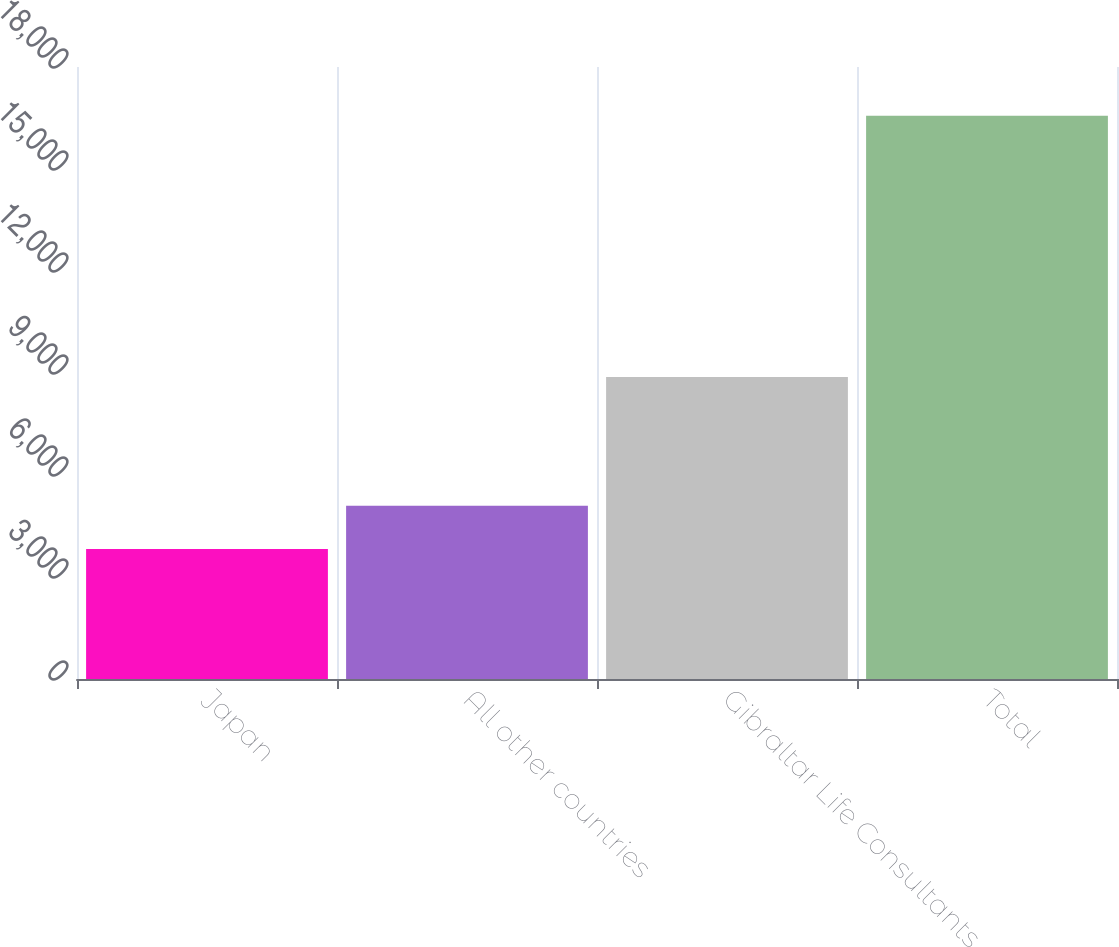Convert chart. <chart><loc_0><loc_0><loc_500><loc_500><bar_chart><fcel>Japan<fcel>All other countries<fcel>Gibraltar Life Consultants<fcel>Total<nl><fcel>3824<fcel>5098<fcel>8884<fcel>16564<nl></chart> 